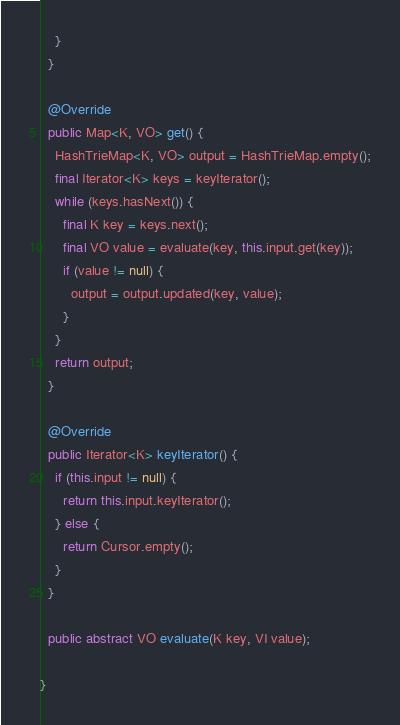Convert code to text. <code><loc_0><loc_0><loc_500><loc_500><_Java_>    }
  }

  @Override
  public Map<K, VO> get() {
    HashTrieMap<K, VO> output = HashTrieMap.empty();
    final Iterator<K> keys = keyIterator();
    while (keys.hasNext()) {
      final K key = keys.next();
      final VO value = evaluate(key, this.input.get(key));
      if (value != null) {
        output = output.updated(key, value);
      }
    }
    return output;
  }

  @Override
  public Iterator<K> keyIterator() {
    if (this.input != null) {
      return this.input.keyIterator();
    } else {
      return Cursor.empty();
    }
  }

  public abstract VO evaluate(K key, VI value);

}
</code> 